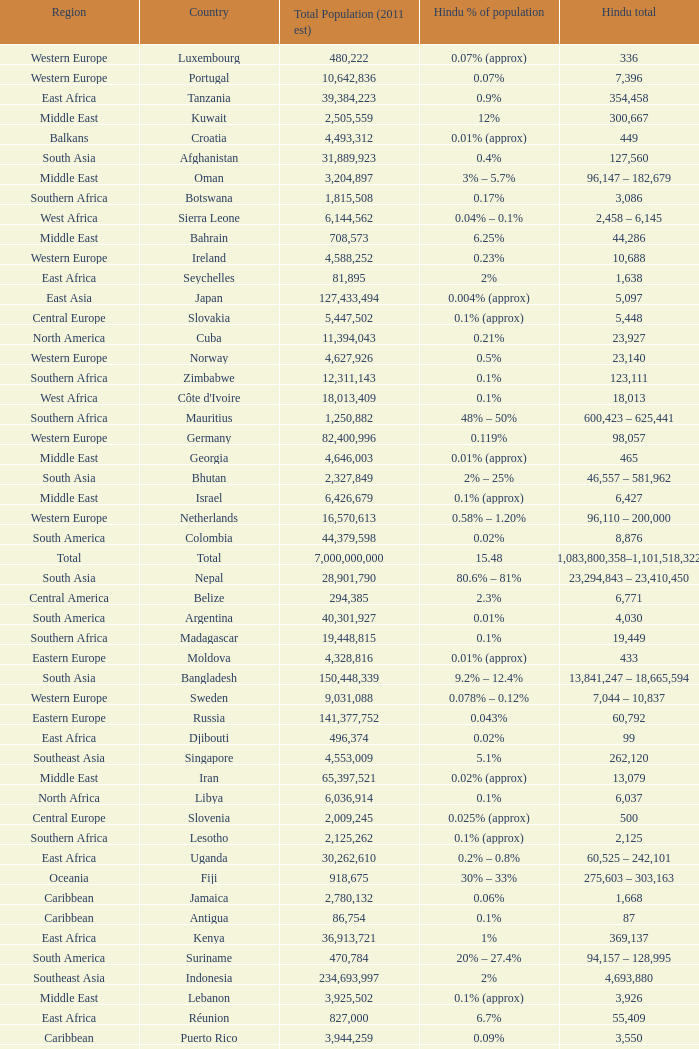Total Population (2011 est) larger than 30,262,610, and a Hindu total of 63,718 involves what country? France. 